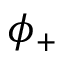Convert formula to latex. <formula><loc_0><loc_0><loc_500><loc_500>\phi _ { + }</formula> 